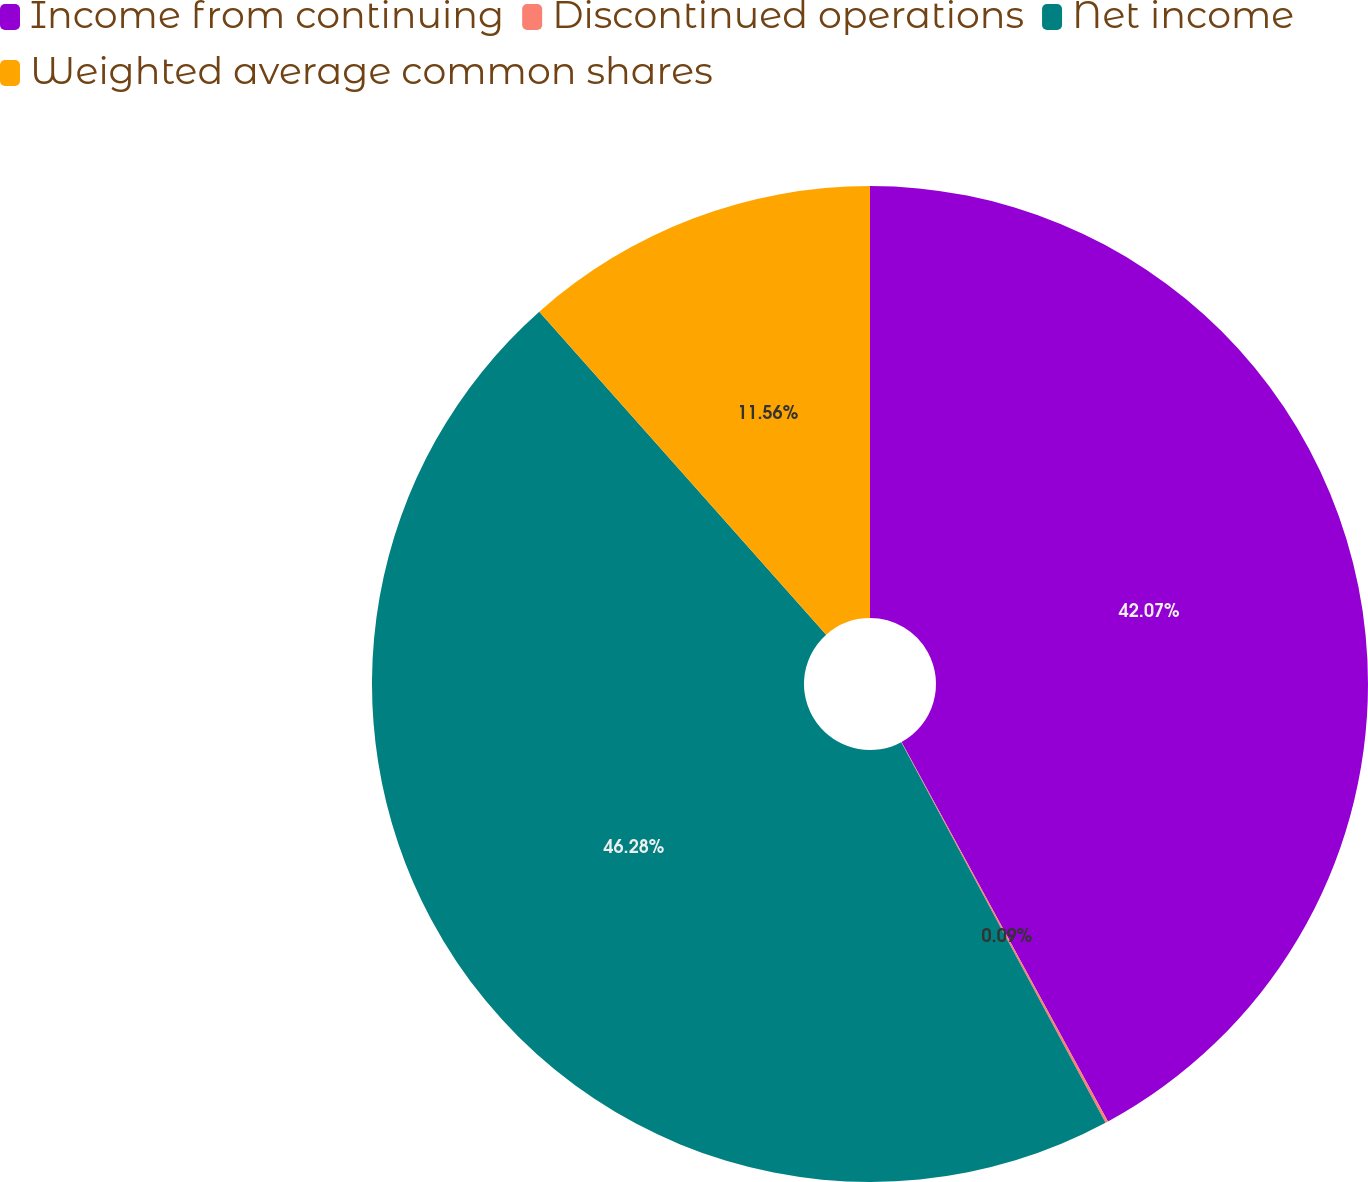Convert chart to OTSL. <chart><loc_0><loc_0><loc_500><loc_500><pie_chart><fcel>Income from continuing<fcel>Discontinued operations<fcel>Net income<fcel>Weighted average common shares<nl><fcel>42.07%<fcel>0.09%<fcel>46.28%<fcel>11.56%<nl></chart> 